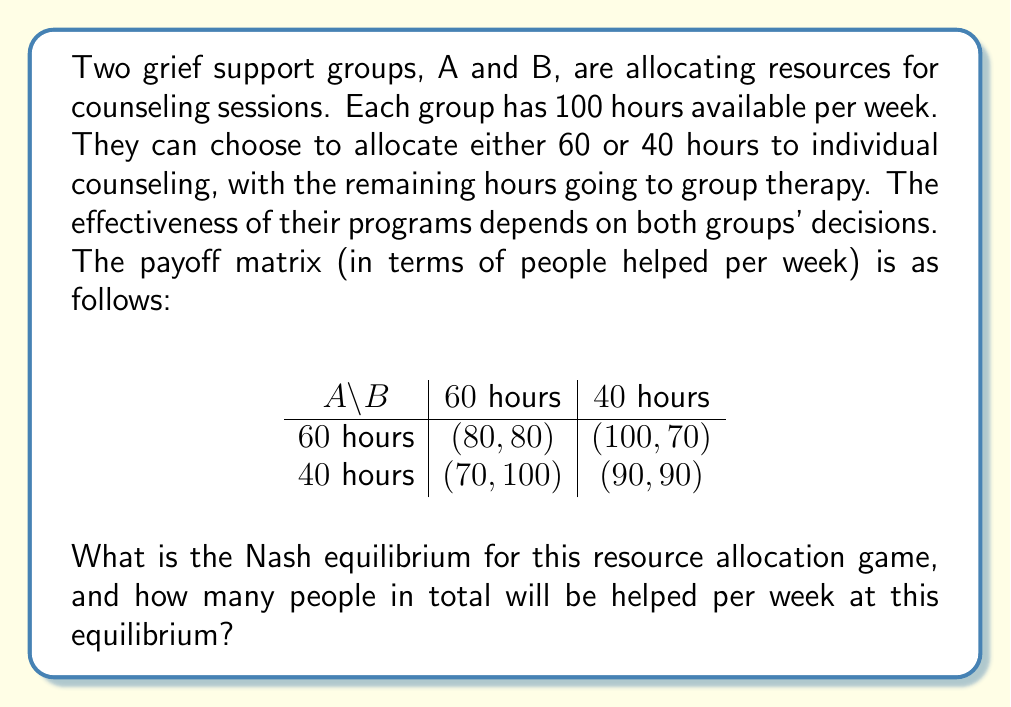Provide a solution to this math problem. To find the Nash equilibrium, we need to analyze each group's best response to the other group's strategy:

1. If Group B chooses 60 hours:
   - Group A's payoff: 80 (if 60 hours) vs 70 (if 40 hours)
   - Group A's best response: 60 hours

2. If Group B chooses 40 hours:
   - Group A's payoff: 100 (if 60 hours) vs 90 (if 40 hours)
   - Group A's best response: 60 hours

3. If Group A chooses 60 hours:
   - Group B's payoff: 80 (if 60 hours) vs 70 (if 40 hours)
   - Group B's best response: 60 hours

4. If Group A chooses 40 hours:
   - Group B's payoff: 100 (if 60 hours) vs 90 (if 40 hours)
   - Group B's best response: 60 hours

We can see that regardless of what the other group does, each group's best strategy is to allocate 60 hours to individual counseling. This makes (60 hours, 60 hours) a Nash equilibrium.

At this equilibrium, both groups will help 80 people per week, for a total of 160 people helped.

This solution demonstrates how even in a competitive setting, grief support groups can find a stable strategy that benefits many people. As a pastor, understanding this equilibrium can help in coordinating resources with other support groups to maximize the number of people receiving comfort and counseling.
Answer: The Nash equilibrium is (60 hours, 60 hours), resulting in a total of 160 people helped per week. 